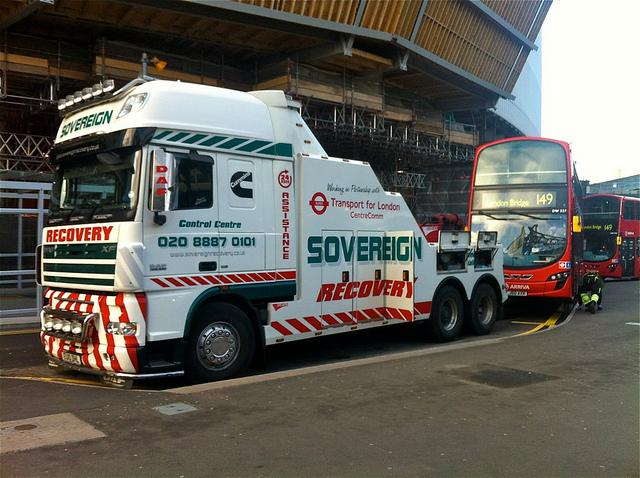Where is Sovereign Recovery located?

Choices:
A) st albans
B) london
C) st. louis
D) tuscany st albans 